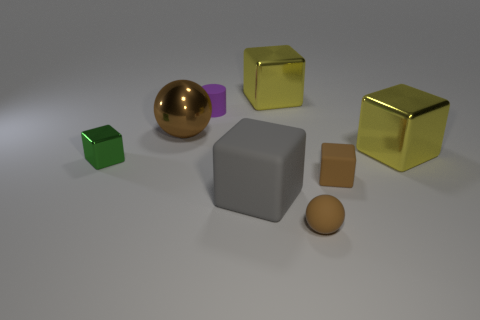Subtract all brown balls. How many were subtracted if there are1brown balls left? 1 Subtract all yellow balls. How many yellow blocks are left? 2 Add 2 large red metallic cylinders. How many objects exist? 10 Subtract all big gray cubes. How many cubes are left? 4 Subtract all balls. How many objects are left? 6 Subtract all brown cubes. How many cubes are left? 4 Subtract all gray cubes. Subtract all yellow balls. How many cubes are left? 4 Subtract all cylinders. Subtract all purple metal blocks. How many objects are left? 7 Add 1 tiny green cubes. How many tiny green cubes are left? 2 Add 2 tiny brown things. How many tiny brown things exist? 4 